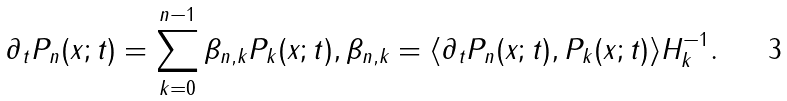Convert formula to latex. <formula><loc_0><loc_0><loc_500><loc_500>\partial _ { t } P _ { n } ( x ; t ) = \sum _ { k = 0 } ^ { n - 1 } \beta _ { n , k } P _ { k } ( x ; t ) , \beta _ { n , k } = \langle \partial _ { t } P _ { n } ( x ; t ) , P _ { k } ( x ; t ) \rangle H _ { k } ^ { - 1 } .</formula> 